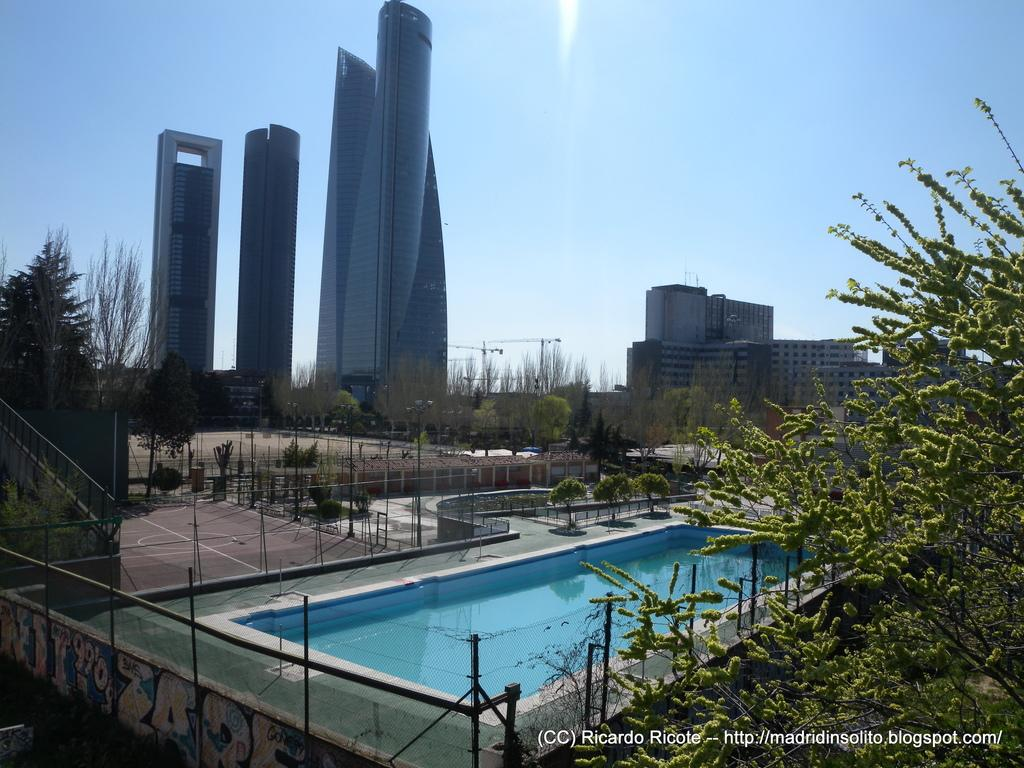Where was the image taken? The image was clicked outside. What can be seen at the bottom of the image? There is a swimming pool at the bottom of the image. What is located in the middle of the image? There are trees and buildings in the middle of the image. What is visible at the top of the image? The sky is visible at the top of the image. Are there any icicles hanging from the trees in the image? No, there are no icicles present in the image, as it was taken outside and the trees are not covered in ice. Can you see anyone trying to crush a collar in the image? There is no one attempting to crush a collar in the image, as the focus is on the swimming pool, trees, buildings, and sky. 